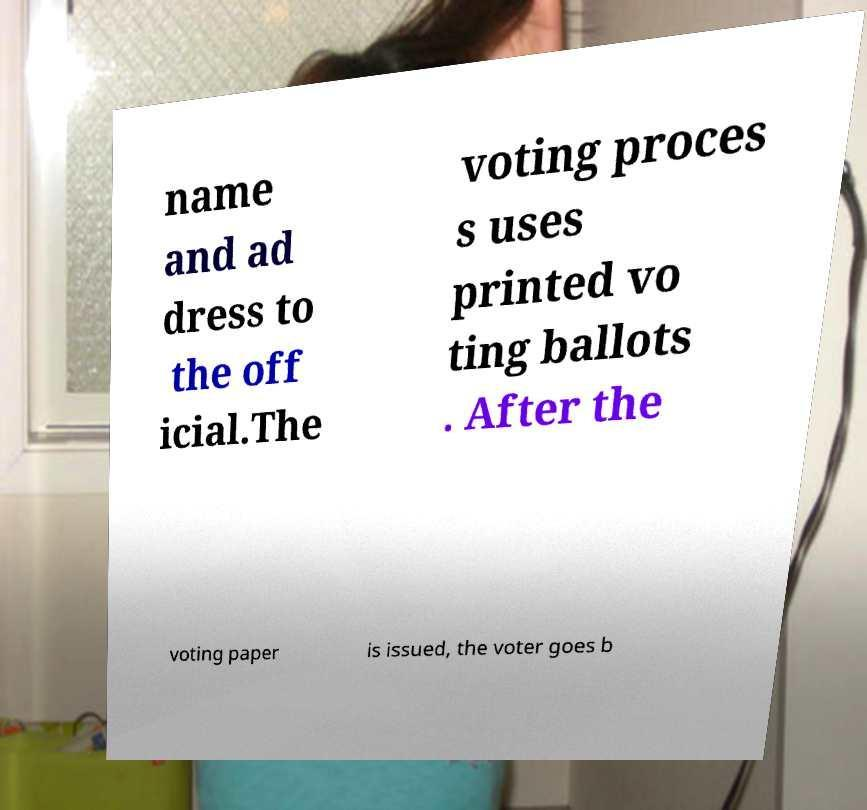For documentation purposes, I need the text within this image transcribed. Could you provide that? name and ad dress to the off icial.The voting proces s uses printed vo ting ballots . After the voting paper is issued, the voter goes b 